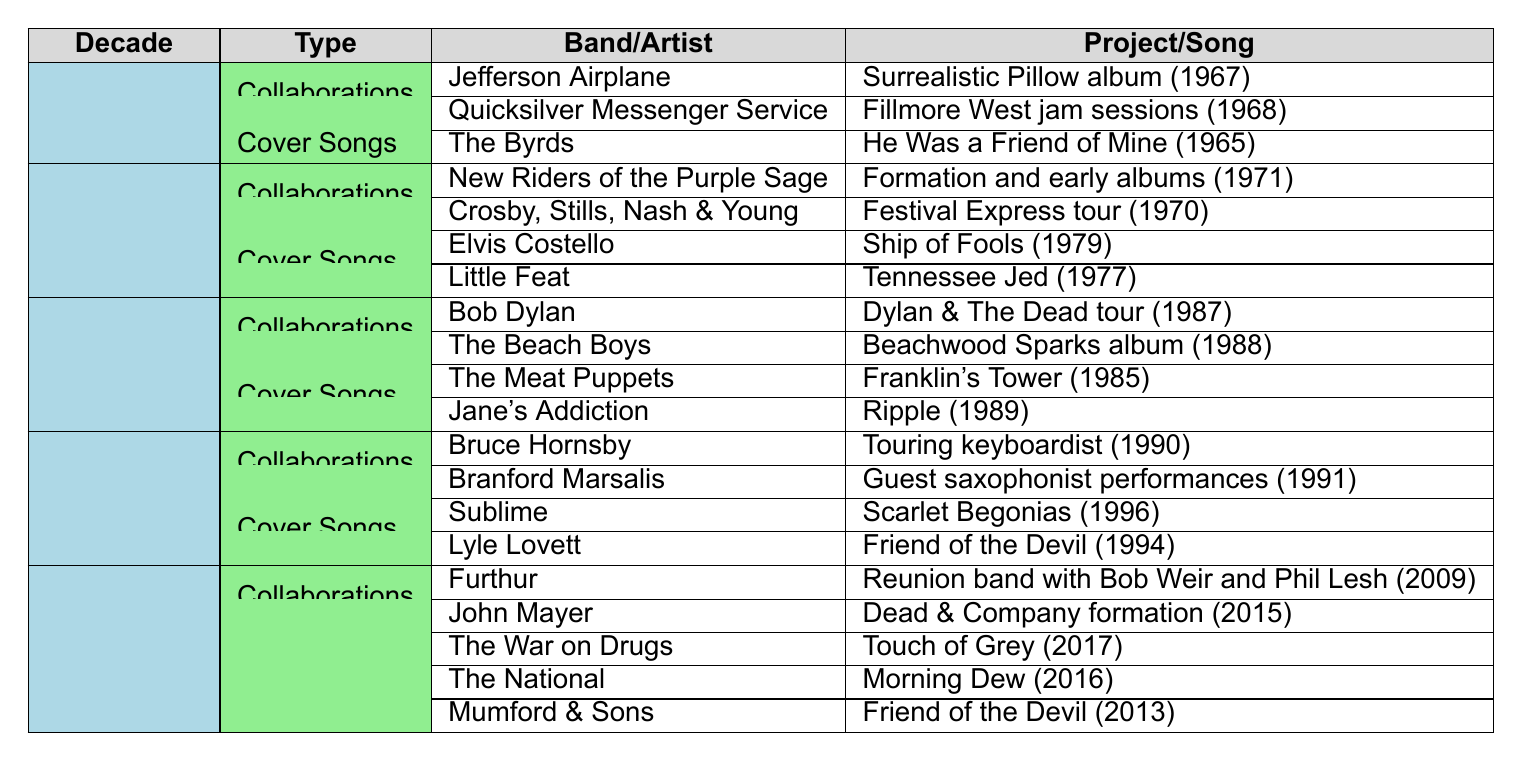What collaboration did the Grateful Dead have with Jefferson Airplane? The table indicates that the Grateful Dead collaborated with Jefferson Airplane on the "Surrealistic Pillow" album in 1967.
Answer: Surrealistic Pillow album (1967) How many cover songs were recorded by other bands in the 1970s? The table shows two cover songs performed by other bands in the 1970s: "Ship of Fools" by Elvis Costello and "Tennessee Jed" by Little Feat. Therefore, the total is 2.
Answer: 2 Which decade saw collaborations with both Bob Dylan and The Beach Boys? The table shows that both Bob Dylan (Dylan & The Dead tour, 1987) and The Beach Boys (Beachwood Sparks album, 1988) collaborated in the 1980s.
Answer: 1980s Did the Grateful Dead have any interactions with bands in the 1990s? Yes, according to the table, they collaborated with Bruce Hornsby and Branford Marsalis in the 1990s.
Answer: Yes What are the names of the cover songs performed in the 1990s? The table lists two cover songs from the 1990s: "Scarlet Begonias" by Sublime and "Friend of the Devil" by Lyle Lovett.
Answer: Scarlet Begonias, Friend of the Devil Which band recorded a cover of "Friend of the Devil" in the 2000s and in what year? The table indicates that both Mumford & Sons (2013) and Lyle Lovett (1994) recorded covers of "Friend of the Devil", but the focus is on Mumford & Sons in the 2000s, releasing it in 2013.
Answer: Mumford & Sons (2013) How many total collaborations are listed across all decades? The total number of collaborations can be calculated: 2 (1960s) + 2 (1970s) + 2 (1980s) + 2 (1990s) + 2 (2000s and beyond) = 10.
Answer: 10 Which decade had the highest number of cover songs listed? The table shows that the 2000s and beyond had 3 cover songs (The War on Drugs, The National, Mumford & Sons), which is more than any other decade.
Answer: 2000s and beyond What is the earliest year listed for a collaboration in the table? The earliest year mentioned for a collaboration is 1967, which corresponds to the Grateful Dead's collaboration with Jefferson Airplane on the "Surrealistic Pillow" album.
Answer: 1967 Which band worked with the Grateful Dead in their project involving the Formation and early albums? The table states that New Riders of the Purple Sage collaborated with the Grateful Dead on their Formation and early albums in 1971.
Answer: New Riders of the Purple Sage Is there any notable pattern in the years when collaborations occurred? Yes, upon reviewing the table, collaborations appear fairly consistently throughout the decades without significant interruption, indicating a sustained influence across time.
Answer: Yes 